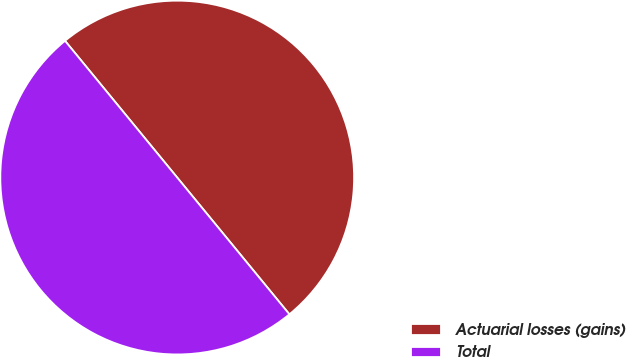Convert chart. <chart><loc_0><loc_0><loc_500><loc_500><pie_chart><fcel>Actuarial losses (gains)<fcel>Total<nl><fcel>50.0%<fcel>50.0%<nl></chart> 